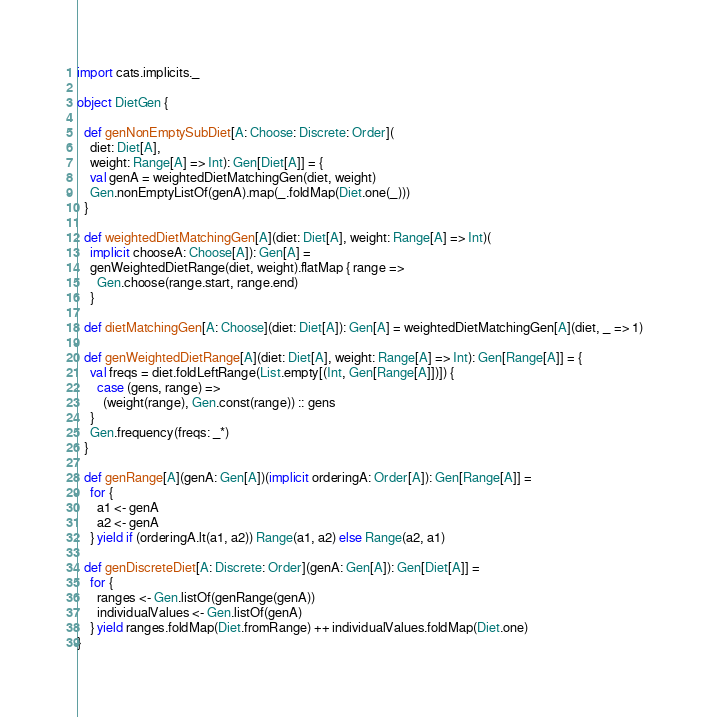Convert code to text. <code><loc_0><loc_0><loc_500><loc_500><_Scala_>import cats.implicits._

object DietGen {

  def genNonEmptySubDiet[A: Choose: Discrete: Order](
    diet: Diet[A],
    weight: Range[A] => Int): Gen[Diet[A]] = {
    val genA = weightedDietMatchingGen(diet, weight)
    Gen.nonEmptyListOf(genA).map(_.foldMap(Diet.one(_)))
  }

  def weightedDietMatchingGen[A](diet: Diet[A], weight: Range[A] => Int)(
    implicit chooseA: Choose[A]): Gen[A] =
    genWeightedDietRange(diet, weight).flatMap { range =>
      Gen.choose(range.start, range.end)
    }

  def dietMatchingGen[A: Choose](diet: Diet[A]): Gen[A] = weightedDietMatchingGen[A](diet, _ => 1)

  def genWeightedDietRange[A](diet: Diet[A], weight: Range[A] => Int): Gen[Range[A]] = {
    val freqs = diet.foldLeftRange(List.empty[(Int, Gen[Range[A]])]) {
      case (gens, range) =>
        (weight(range), Gen.const(range)) :: gens
    }
    Gen.frequency(freqs: _*)
  }

  def genRange[A](genA: Gen[A])(implicit orderingA: Order[A]): Gen[Range[A]] =
    for {
      a1 <- genA
      a2 <- genA
    } yield if (orderingA.lt(a1, a2)) Range(a1, a2) else Range(a2, a1)

  def genDiscreteDiet[A: Discrete: Order](genA: Gen[A]): Gen[Diet[A]] =
    for {
      ranges <- Gen.listOf(genRange(genA))
      individualValues <- Gen.listOf(genA)
    } yield ranges.foldMap(Diet.fromRange) ++ individualValues.foldMap(Diet.one)
}
</code> 